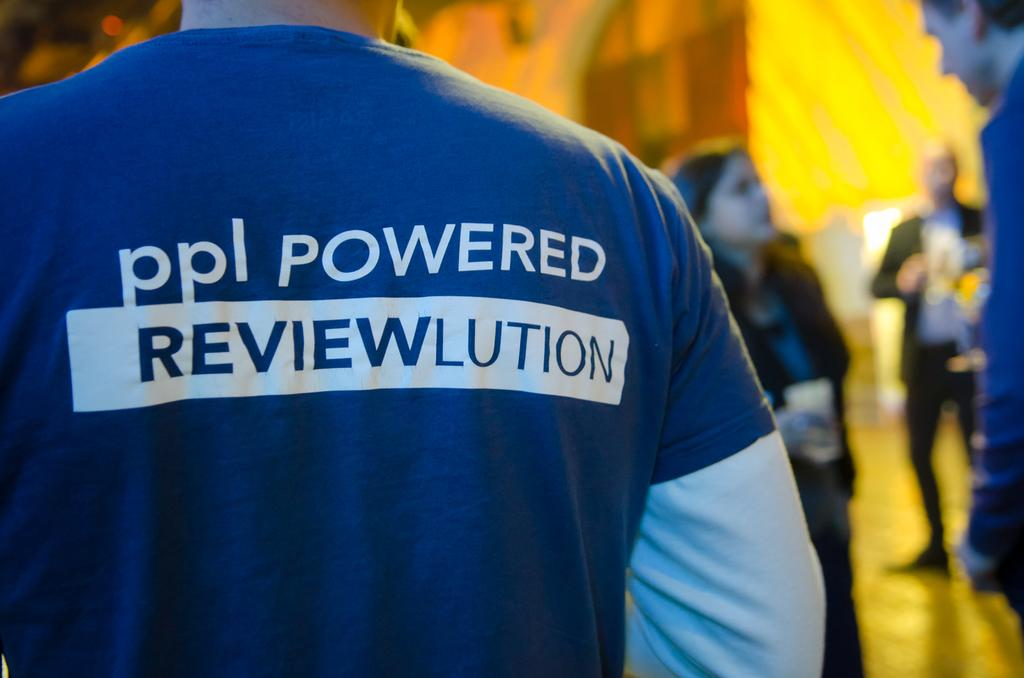<image>
Provide a brief description of the given image. A man wearing a shirt that says ppl powered Reviewlution. 